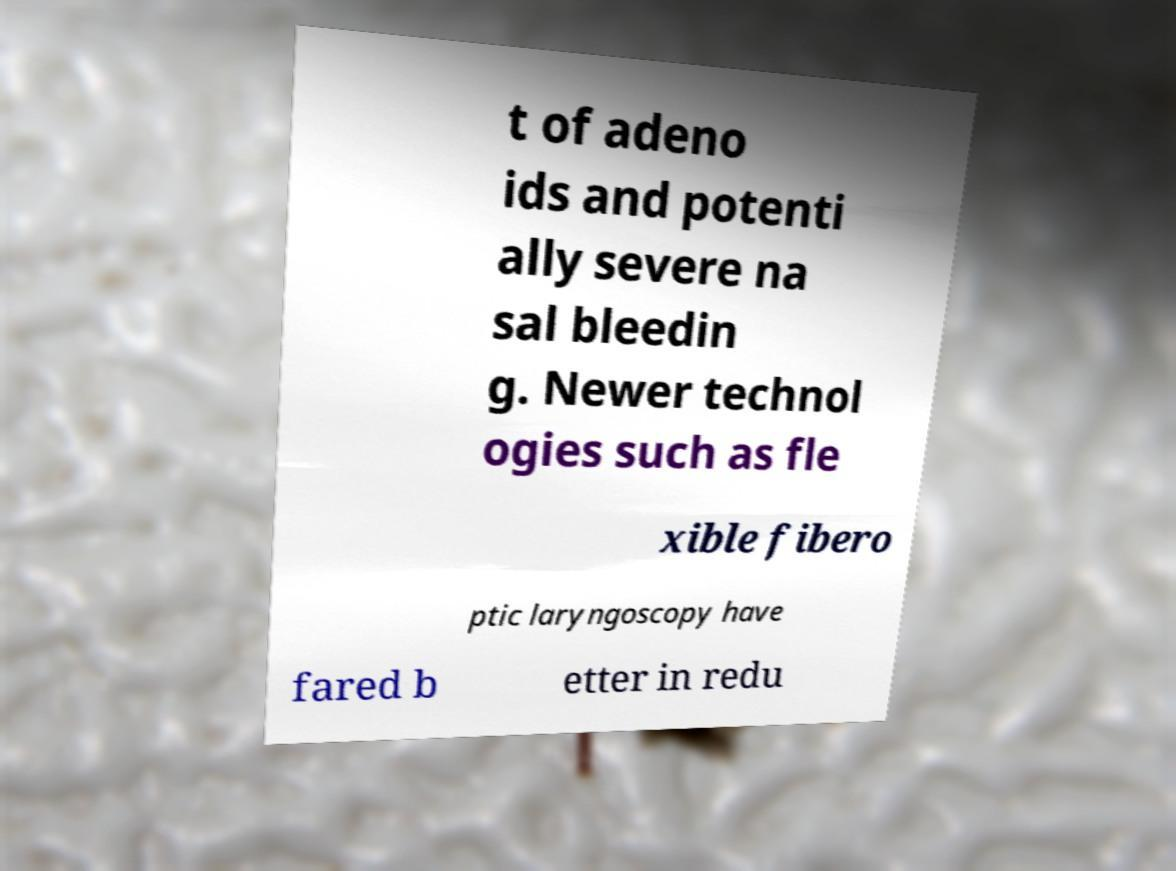There's text embedded in this image that I need extracted. Can you transcribe it verbatim? t of adeno ids and potenti ally severe na sal bleedin g. Newer technol ogies such as fle xible fibero ptic laryngoscopy have fared b etter in redu 